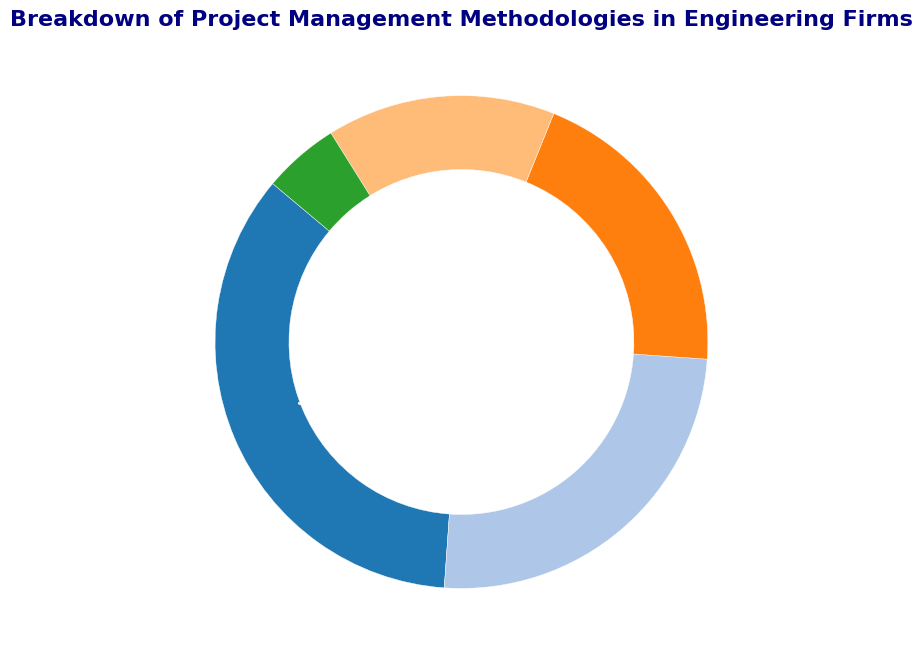What percentage of firms use methodologies other than Agile or Waterfall? First, identify the percentages for Agile and Waterfall from the chart, which are 35% and 25% respectively. Add these values to get 60%. Subtract this value from 100% to find the percentage of firms using other methodologies: 100% - 60% = 40%.
Answer: 40% Which methodology is less popular than Scrum but more popular than Others? Scrum is at 20% and Others are at 5%. The only methodology between these two percentages is Kanban at 15%.
Answer: Kanban What is the combined percentage of firms using Scrum and Kanban? Look at the percentages for Scrum and Kanban from the chart, which are 20% and 15% respectively. Add these to get the total: 20% + 15% = 35%.
Answer: 35% How many times more popular is Agile than Others? Agile represents 35% while Others represent 5%. To determine how many times more popular Agile is, divide the percentage of Agile by Others: 35% / 5% = 7.
Answer: 7 times Which methodology has the highest representation in the pie chart? By observing the percentages in the chart, Agile has the highest representation at 35%.
Answer: Agile What is the difference in percentage between the most and least popular methodologies? The most popular methodology is Agile at 35%, and the least popular is Others at 5%. Subtract 5% from 35% to find the difference: 35% - 5% = 30%.
Answer: 30% If an engineering firm is picked at random, what is the probability that it uses Waterfall or Agile methodologies? The percentage for Waterfall is 25% and for Agile is 35%. Add these to get the total percentage: 25% + 35% = 60%. The probability in percentage is 60%.
Answer: 60% How much larger is the segment for Kanban compared to Others? Kanban is 15% while Others is 5%. Subtract 5% from 15% to get the difference: 15% - 5% = 10%. So, 10% larger.
Answer: 10% 